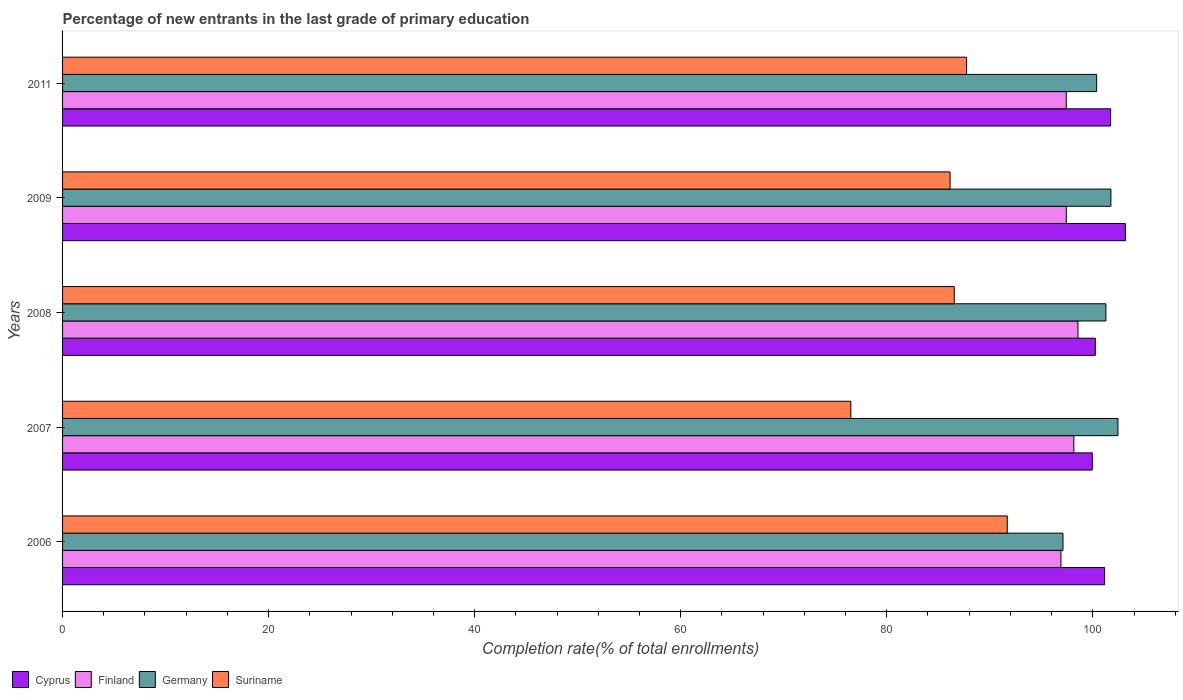How many different coloured bars are there?
Make the answer very short. 4. How many bars are there on the 3rd tick from the top?
Your answer should be very brief. 4. In how many cases, is the number of bars for a given year not equal to the number of legend labels?
Your answer should be very brief. 0. What is the percentage of new entrants in Finland in 2009?
Offer a terse response. 97.43. Across all years, what is the maximum percentage of new entrants in Suriname?
Offer a terse response. 91.7. Across all years, what is the minimum percentage of new entrants in Cyprus?
Provide a short and direct response. 99.95. In which year was the percentage of new entrants in Germany maximum?
Keep it short and to the point. 2007. In which year was the percentage of new entrants in Finland minimum?
Your answer should be very brief. 2006. What is the total percentage of new entrants in Cyprus in the graph?
Your answer should be compact. 506.24. What is the difference between the percentage of new entrants in Suriname in 2006 and that in 2008?
Give a very brief answer. 5.15. What is the difference between the percentage of new entrants in Germany in 2009 and the percentage of new entrants in Finland in 2008?
Offer a very short reply. 3.2. What is the average percentage of new entrants in Suriname per year?
Your answer should be compact. 85.73. In the year 2008, what is the difference between the percentage of new entrants in Germany and percentage of new entrants in Finland?
Keep it short and to the point. 2.71. What is the ratio of the percentage of new entrants in Germany in 2008 to that in 2009?
Provide a succinct answer. 1. Is the percentage of new entrants in Cyprus in 2006 less than that in 2009?
Your answer should be very brief. Yes. Is the difference between the percentage of new entrants in Germany in 2006 and 2009 greater than the difference between the percentage of new entrants in Finland in 2006 and 2009?
Your answer should be very brief. No. What is the difference between the highest and the second highest percentage of new entrants in Finland?
Provide a short and direct response. 0.4. What is the difference between the highest and the lowest percentage of new entrants in Finland?
Ensure brevity in your answer.  1.65. What does the 1st bar from the top in 2007 represents?
Your response must be concise. Suriname. What does the 4th bar from the bottom in 2008 represents?
Ensure brevity in your answer.  Suriname. Is it the case that in every year, the sum of the percentage of new entrants in Germany and percentage of new entrants in Suriname is greater than the percentage of new entrants in Finland?
Give a very brief answer. Yes. Does the graph contain grids?
Ensure brevity in your answer.  No. How many legend labels are there?
Make the answer very short. 4. How are the legend labels stacked?
Ensure brevity in your answer.  Horizontal. What is the title of the graph?
Offer a very short reply. Percentage of new entrants in the last grade of primary education. What is the label or title of the X-axis?
Offer a very short reply. Completion rate(% of total enrollments). What is the label or title of the Y-axis?
Give a very brief answer. Years. What is the Completion rate(% of total enrollments) in Cyprus in 2006?
Make the answer very short. 101.15. What is the Completion rate(% of total enrollments) in Finland in 2006?
Your answer should be very brief. 96.91. What is the Completion rate(% of total enrollments) in Germany in 2006?
Ensure brevity in your answer.  97.11. What is the Completion rate(% of total enrollments) of Suriname in 2006?
Make the answer very short. 91.7. What is the Completion rate(% of total enrollments) of Cyprus in 2007?
Give a very brief answer. 99.95. What is the Completion rate(% of total enrollments) in Finland in 2007?
Provide a short and direct response. 98.16. What is the Completion rate(% of total enrollments) in Germany in 2007?
Make the answer very short. 102.44. What is the Completion rate(% of total enrollments) in Suriname in 2007?
Provide a short and direct response. 76.51. What is the Completion rate(% of total enrollments) in Cyprus in 2008?
Offer a very short reply. 100.25. What is the Completion rate(% of total enrollments) in Finland in 2008?
Your answer should be very brief. 98.56. What is the Completion rate(% of total enrollments) of Germany in 2008?
Offer a very short reply. 101.27. What is the Completion rate(% of total enrollments) of Suriname in 2008?
Give a very brief answer. 86.55. What is the Completion rate(% of total enrollments) of Cyprus in 2009?
Your answer should be very brief. 103.16. What is the Completion rate(% of total enrollments) of Finland in 2009?
Your answer should be compact. 97.43. What is the Completion rate(% of total enrollments) in Germany in 2009?
Provide a succinct answer. 101.76. What is the Completion rate(% of total enrollments) of Suriname in 2009?
Keep it short and to the point. 86.15. What is the Completion rate(% of total enrollments) of Cyprus in 2011?
Offer a very short reply. 101.73. What is the Completion rate(% of total enrollments) of Finland in 2011?
Keep it short and to the point. 97.42. What is the Completion rate(% of total enrollments) in Germany in 2011?
Your response must be concise. 100.37. What is the Completion rate(% of total enrollments) in Suriname in 2011?
Provide a short and direct response. 87.75. Across all years, what is the maximum Completion rate(% of total enrollments) in Cyprus?
Your response must be concise. 103.16. Across all years, what is the maximum Completion rate(% of total enrollments) in Finland?
Provide a succinct answer. 98.56. Across all years, what is the maximum Completion rate(% of total enrollments) in Germany?
Provide a short and direct response. 102.44. Across all years, what is the maximum Completion rate(% of total enrollments) in Suriname?
Offer a terse response. 91.7. Across all years, what is the minimum Completion rate(% of total enrollments) in Cyprus?
Your answer should be very brief. 99.95. Across all years, what is the minimum Completion rate(% of total enrollments) of Finland?
Provide a succinct answer. 96.91. Across all years, what is the minimum Completion rate(% of total enrollments) in Germany?
Your response must be concise. 97.11. Across all years, what is the minimum Completion rate(% of total enrollments) in Suriname?
Ensure brevity in your answer.  76.51. What is the total Completion rate(% of total enrollments) in Cyprus in the graph?
Offer a very short reply. 506.24. What is the total Completion rate(% of total enrollments) in Finland in the graph?
Give a very brief answer. 488.48. What is the total Completion rate(% of total enrollments) in Germany in the graph?
Ensure brevity in your answer.  502.96. What is the total Completion rate(% of total enrollments) of Suriname in the graph?
Offer a terse response. 428.65. What is the difference between the Completion rate(% of total enrollments) of Cyprus in 2006 and that in 2007?
Your answer should be compact. 1.19. What is the difference between the Completion rate(% of total enrollments) in Finland in 2006 and that in 2007?
Provide a short and direct response. -1.25. What is the difference between the Completion rate(% of total enrollments) of Germany in 2006 and that in 2007?
Your response must be concise. -5.34. What is the difference between the Completion rate(% of total enrollments) in Suriname in 2006 and that in 2007?
Provide a succinct answer. 15.19. What is the difference between the Completion rate(% of total enrollments) in Finland in 2006 and that in 2008?
Provide a succinct answer. -1.65. What is the difference between the Completion rate(% of total enrollments) of Germany in 2006 and that in 2008?
Provide a succinct answer. -4.17. What is the difference between the Completion rate(% of total enrollments) of Suriname in 2006 and that in 2008?
Provide a short and direct response. 5.15. What is the difference between the Completion rate(% of total enrollments) in Cyprus in 2006 and that in 2009?
Keep it short and to the point. -2.01. What is the difference between the Completion rate(% of total enrollments) in Finland in 2006 and that in 2009?
Your response must be concise. -0.52. What is the difference between the Completion rate(% of total enrollments) of Germany in 2006 and that in 2009?
Offer a terse response. -4.65. What is the difference between the Completion rate(% of total enrollments) of Suriname in 2006 and that in 2009?
Offer a terse response. 5.55. What is the difference between the Completion rate(% of total enrollments) of Cyprus in 2006 and that in 2011?
Ensure brevity in your answer.  -0.59. What is the difference between the Completion rate(% of total enrollments) of Finland in 2006 and that in 2011?
Give a very brief answer. -0.52. What is the difference between the Completion rate(% of total enrollments) of Germany in 2006 and that in 2011?
Offer a very short reply. -3.27. What is the difference between the Completion rate(% of total enrollments) in Suriname in 2006 and that in 2011?
Your answer should be very brief. 3.95. What is the difference between the Completion rate(% of total enrollments) of Cyprus in 2007 and that in 2008?
Your answer should be very brief. -0.29. What is the difference between the Completion rate(% of total enrollments) of Finland in 2007 and that in 2008?
Provide a short and direct response. -0.4. What is the difference between the Completion rate(% of total enrollments) of Germany in 2007 and that in 2008?
Keep it short and to the point. 1.17. What is the difference between the Completion rate(% of total enrollments) in Suriname in 2007 and that in 2008?
Offer a terse response. -10.04. What is the difference between the Completion rate(% of total enrollments) in Cyprus in 2007 and that in 2009?
Your answer should be compact. -3.21. What is the difference between the Completion rate(% of total enrollments) of Finland in 2007 and that in 2009?
Your response must be concise. 0.73. What is the difference between the Completion rate(% of total enrollments) of Germany in 2007 and that in 2009?
Provide a succinct answer. 0.69. What is the difference between the Completion rate(% of total enrollments) in Suriname in 2007 and that in 2009?
Provide a short and direct response. -9.64. What is the difference between the Completion rate(% of total enrollments) in Cyprus in 2007 and that in 2011?
Make the answer very short. -1.78. What is the difference between the Completion rate(% of total enrollments) of Finland in 2007 and that in 2011?
Keep it short and to the point. 0.74. What is the difference between the Completion rate(% of total enrollments) in Germany in 2007 and that in 2011?
Make the answer very short. 2.07. What is the difference between the Completion rate(% of total enrollments) in Suriname in 2007 and that in 2011?
Provide a short and direct response. -11.23. What is the difference between the Completion rate(% of total enrollments) in Cyprus in 2008 and that in 2009?
Provide a short and direct response. -2.91. What is the difference between the Completion rate(% of total enrollments) in Finland in 2008 and that in 2009?
Your response must be concise. 1.13. What is the difference between the Completion rate(% of total enrollments) in Germany in 2008 and that in 2009?
Keep it short and to the point. -0.49. What is the difference between the Completion rate(% of total enrollments) of Suriname in 2008 and that in 2009?
Your answer should be compact. 0.41. What is the difference between the Completion rate(% of total enrollments) of Cyprus in 2008 and that in 2011?
Give a very brief answer. -1.49. What is the difference between the Completion rate(% of total enrollments) in Finland in 2008 and that in 2011?
Your response must be concise. 1.14. What is the difference between the Completion rate(% of total enrollments) of Germany in 2008 and that in 2011?
Provide a succinct answer. 0.9. What is the difference between the Completion rate(% of total enrollments) of Suriname in 2008 and that in 2011?
Your answer should be compact. -1.19. What is the difference between the Completion rate(% of total enrollments) in Cyprus in 2009 and that in 2011?
Ensure brevity in your answer.  1.43. What is the difference between the Completion rate(% of total enrollments) of Finland in 2009 and that in 2011?
Your answer should be compact. 0. What is the difference between the Completion rate(% of total enrollments) in Germany in 2009 and that in 2011?
Keep it short and to the point. 1.38. What is the difference between the Completion rate(% of total enrollments) in Suriname in 2009 and that in 2011?
Offer a terse response. -1.6. What is the difference between the Completion rate(% of total enrollments) of Cyprus in 2006 and the Completion rate(% of total enrollments) of Finland in 2007?
Provide a short and direct response. 2.99. What is the difference between the Completion rate(% of total enrollments) of Cyprus in 2006 and the Completion rate(% of total enrollments) of Germany in 2007?
Provide a succinct answer. -1.3. What is the difference between the Completion rate(% of total enrollments) in Cyprus in 2006 and the Completion rate(% of total enrollments) in Suriname in 2007?
Your response must be concise. 24.63. What is the difference between the Completion rate(% of total enrollments) in Finland in 2006 and the Completion rate(% of total enrollments) in Germany in 2007?
Ensure brevity in your answer.  -5.54. What is the difference between the Completion rate(% of total enrollments) in Finland in 2006 and the Completion rate(% of total enrollments) in Suriname in 2007?
Your answer should be compact. 20.4. What is the difference between the Completion rate(% of total enrollments) of Germany in 2006 and the Completion rate(% of total enrollments) of Suriname in 2007?
Keep it short and to the point. 20.6. What is the difference between the Completion rate(% of total enrollments) in Cyprus in 2006 and the Completion rate(% of total enrollments) in Finland in 2008?
Your answer should be very brief. 2.58. What is the difference between the Completion rate(% of total enrollments) of Cyprus in 2006 and the Completion rate(% of total enrollments) of Germany in 2008?
Your response must be concise. -0.13. What is the difference between the Completion rate(% of total enrollments) in Cyprus in 2006 and the Completion rate(% of total enrollments) in Suriname in 2008?
Give a very brief answer. 14.59. What is the difference between the Completion rate(% of total enrollments) in Finland in 2006 and the Completion rate(% of total enrollments) in Germany in 2008?
Your response must be concise. -4.36. What is the difference between the Completion rate(% of total enrollments) of Finland in 2006 and the Completion rate(% of total enrollments) of Suriname in 2008?
Offer a terse response. 10.36. What is the difference between the Completion rate(% of total enrollments) of Germany in 2006 and the Completion rate(% of total enrollments) of Suriname in 2008?
Your answer should be very brief. 10.55. What is the difference between the Completion rate(% of total enrollments) of Cyprus in 2006 and the Completion rate(% of total enrollments) of Finland in 2009?
Make the answer very short. 3.72. What is the difference between the Completion rate(% of total enrollments) of Cyprus in 2006 and the Completion rate(% of total enrollments) of Germany in 2009?
Provide a succinct answer. -0.61. What is the difference between the Completion rate(% of total enrollments) in Cyprus in 2006 and the Completion rate(% of total enrollments) in Suriname in 2009?
Provide a short and direct response. 15. What is the difference between the Completion rate(% of total enrollments) of Finland in 2006 and the Completion rate(% of total enrollments) of Germany in 2009?
Offer a very short reply. -4.85. What is the difference between the Completion rate(% of total enrollments) in Finland in 2006 and the Completion rate(% of total enrollments) in Suriname in 2009?
Offer a terse response. 10.76. What is the difference between the Completion rate(% of total enrollments) of Germany in 2006 and the Completion rate(% of total enrollments) of Suriname in 2009?
Your answer should be very brief. 10.96. What is the difference between the Completion rate(% of total enrollments) in Cyprus in 2006 and the Completion rate(% of total enrollments) in Finland in 2011?
Provide a succinct answer. 3.72. What is the difference between the Completion rate(% of total enrollments) in Cyprus in 2006 and the Completion rate(% of total enrollments) in Germany in 2011?
Your answer should be compact. 0.77. What is the difference between the Completion rate(% of total enrollments) of Cyprus in 2006 and the Completion rate(% of total enrollments) of Suriname in 2011?
Make the answer very short. 13.4. What is the difference between the Completion rate(% of total enrollments) of Finland in 2006 and the Completion rate(% of total enrollments) of Germany in 2011?
Your response must be concise. -3.47. What is the difference between the Completion rate(% of total enrollments) in Finland in 2006 and the Completion rate(% of total enrollments) in Suriname in 2011?
Keep it short and to the point. 9.16. What is the difference between the Completion rate(% of total enrollments) in Germany in 2006 and the Completion rate(% of total enrollments) in Suriname in 2011?
Give a very brief answer. 9.36. What is the difference between the Completion rate(% of total enrollments) in Cyprus in 2007 and the Completion rate(% of total enrollments) in Finland in 2008?
Your answer should be compact. 1.39. What is the difference between the Completion rate(% of total enrollments) in Cyprus in 2007 and the Completion rate(% of total enrollments) in Germany in 2008?
Ensure brevity in your answer.  -1.32. What is the difference between the Completion rate(% of total enrollments) in Cyprus in 2007 and the Completion rate(% of total enrollments) in Suriname in 2008?
Make the answer very short. 13.4. What is the difference between the Completion rate(% of total enrollments) of Finland in 2007 and the Completion rate(% of total enrollments) of Germany in 2008?
Make the answer very short. -3.11. What is the difference between the Completion rate(% of total enrollments) in Finland in 2007 and the Completion rate(% of total enrollments) in Suriname in 2008?
Give a very brief answer. 11.61. What is the difference between the Completion rate(% of total enrollments) of Germany in 2007 and the Completion rate(% of total enrollments) of Suriname in 2008?
Your response must be concise. 15.89. What is the difference between the Completion rate(% of total enrollments) of Cyprus in 2007 and the Completion rate(% of total enrollments) of Finland in 2009?
Your response must be concise. 2.52. What is the difference between the Completion rate(% of total enrollments) in Cyprus in 2007 and the Completion rate(% of total enrollments) in Germany in 2009?
Your answer should be very brief. -1.81. What is the difference between the Completion rate(% of total enrollments) of Cyprus in 2007 and the Completion rate(% of total enrollments) of Suriname in 2009?
Your answer should be very brief. 13.8. What is the difference between the Completion rate(% of total enrollments) in Finland in 2007 and the Completion rate(% of total enrollments) in Germany in 2009?
Provide a short and direct response. -3.6. What is the difference between the Completion rate(% of total enrollments) of Finland in 2007 and the Completion rate(% of total enrollments) of Suriname in 2009?
Your response must be concise. 12.01. What is the difference between the Completion rate(% of total enrollments) of Germany in 2007 and the Completion rate(% of total enrollments) of Suriname in 2009?
Provide a short and direct response. 16.3. What is the difference between the Completion rate(% of total enrollments) in Cyprus in 2007 and the Completion rate(% of total enrollments) in Finland in 2011?
Make the answer very short. 2.53. What is the difference between the Completion rate(% of total enrollments) of Cyprus in 2007 and the Completion rate(% of total enrollments) of Germany in 2011?
Offer a terse response. -0.42. What is the difference between the Completion rate(% of total enrollments) of Cyprus in 2007 and the Completion rate(% of total enrollments) of Suriname in 2011?
Your answer should be very brief. 12.21. What is the difference between the Completion rate(% of total enrollments) in Finland in 2007 and the Completion rate(% of total enrollments) in Germany in 2011?
Give a very brief answer. -2.21. What is the difference between the Completion rate(% of total enrollments) of Finland in 2007 and the Completion rate(% of total enrollments) of Suriname in 2011?
Provide a short and direct response. 10.42. What is the difference between the Completion rate(% of total enrollments) in Germany in 2007 and the Completion rate(% of total enrollments) in Suriname in 2011?
Give a very brief answer. 14.7. What is the difference between the Completion rate(% of total enrollments) of Cyprus in 2008 and the Completion rate(% of total enrollments) of Finland in 2009?
Your answer should be compact. 2.82. What is the difference between the Completion rate(% of total enrollments) in Cyprus in 2008 and the Completion rate(% of total enrollments) in Germany in 2009?
Provide a short and direct response. -1.51. What is the difference between the Completion rate(% of total enrollments) in Cyprus in 2008 and the Completion rate(% of total enrollments) in Suriname in 2009?
Ensure brevity in your answer.  14.1. What is the difference between the Completion rate(% of total enrollments) in Finland in 2008 and the Completion rate(% of total enrollments) in Germany in 2009?
Your answer should be compact. -3.2. What is the difference between the Completion rate(% of total enrollments) of Finland in 2008 and the Completion rate(% of total enrollments) of Suriname in 2009?
Provide a short and direct response. 12.42. What is the difference between the Completion rate(% of total enrollments) in Germany in 2008 and the Completion rate(% of total enrollments) in Suriname in 2009?
Your answer should be compact. 15.13. What is the difference between the Completion rate(% of total enrollments) of Cyprus in 2008 and the Completion rate(% of total enrollments) of Finland in 2011?
Provide a succinct answer. 2.82. What is the difference between the Completion rate(% of total enrollments) of Cyprus in 2008 and the Completion rate(% of total enrollments) of Germany in 2011?
Ensure brevity in your answer.  -0.13. What is the difference between the Completion rate(% of total enrollments) in Cyprus in 2008 and the Completion rate(% of total enrollments) in Suriname in 2011?
Provide a succinct answer. 12.5. What is the difference between the Completion rate(% of total enrollments) of Finland in 2008 and the Completion rate(% of total enrollments) of Germany in 2011?
Give a very brief answer. -1.81. What is the difference between the Completion rate(% of total enrollments) in Finland in 2008 and the Completion rate(% of total enrollments) in Suriname in 2011?
Provide a succinct answer. 10.82. What is the difference between the Completion rate(% of total enrollments) of Germany in 2008 and the Completion rate(% of total enrollments) of Suriname in 2011?
Your answer should be compact. 13.53. What is the difference between the Completion rate(% of total enrollments) in Cyprus in 2009 and the Completion rate(% of total enrollments) in Finland in 2011?
Ensure brevity in your answer.  5.74. What is the difference between the Completion rate(% of total enrollments) of Cyprus in 2009 and the Completion rate(% of total enrollments) of Germany in 2011?
Make the answer very short. 2.79. What is the difference between the Completion rate(% of total enrollments) in Cyprus in 2009 and the Completion rate(% of total enrollments) in Suriname in 2011?
Make the answer very short. 15.41. What is the difference between the Completion rate(% of total enrollments) in Finland in 2009 and the Completion rate(% of total enrollments) in Germany in 2011?
Your answer should be compact. -2.95. What is the difference between the Completion rate(% of total enrollments) in Finland in 2009 and the Completion rate(% of total enrollments) in Suriname in 2011?
Give a very brief answer. 9.68. What is the difference between the Completion rate(% of total enrollments) of Germany in 2009 and the Completion rate(% of total enrollments) of Suriname in 2011?
Your response must be concise. 14.01. What is the average Completion rate(% of total enrollments) in Cyprus per year?
Make the answer very short. 101.25. What is the average Completion rate(% of total enrollments) in Finland per year?
Provide a succinct answer. 97.7. What is the average Completion rate(% of total enrollments) in Germany per year?
Your answer should be compact. 100.59. What is the average Completion rate(% of total enrollments) in Suriname per year?
Provide a short and direct response. 85.73. In the year 2006, what is the difference between the Completion rate(% of total enrollments) in Cyprus and Completion rate(% of total enrollments) in Finland?
Make the answer very short. 4.24. In the year 2006, what is the difference between the Completion rate(% of total enrollments) in Cyprus and Completion rate(% of total enrollments) in Germany?
Keep it short and to the point. 4.04. In the year 2006, what is the difference between the Completion rate(% of total enrollments) of Cyprus and Completion rate(% of total enrollments) of Suriname?
Provide a short and direct response. 9.45. In the year 2006, what is the difference between the Completion rate(% of total enrollments) in Finland and Completion rate(% of total enrollments) in Germany?
Ensure brevity in your answer.  -0.2. In the year 2006, what is the difference between the Completion rate(% of total enrollments) in Finland and Completion rate(% of total enrollments) in Suriname?
Ensure brevity in your answer.  5.21. In the year 2006, what is the difference between the Completion rate(% of total enrollments) of Germany and Completion rate(% of total enrollments) of Suriname?
Ensure brevity in your answer.  5.41. In the year 2007, what is the difference between the Completion rate(% of total enrollments) of Cyprus and Completion rate(% of total enrollments) of Finland?
Offer a terse response. 1.79. In the year 2007, what is the difference between the Completion rate(% of total enrollments) of Cyprus and Completion rate(% of total enrollments) of Germany?
Ensure brevity in your answer.  -2.49. In the year 2007, what is the difference between the Completion rate(% of total enrollments) in Cyprus and Completion rate(% of total enrollments) in Suriname?
Your answer should be very brief. 23.44. In the year 2007, what is the difference between the Completion rate(% of total enrollments) in Finland and Completion rate(% of total enrollments) in Germany?
Provide a short and direct response. -4.28. In the year 2007, what is the difference between the Completion rate(% of total enrollments) in Finland and Completion rate(% of total enrollments) in Suriname?
Offer a terse response. 21.65. In the year 2007, what is the difference between the Completion rate(% of total enrollments) of Germany and Completion rate(% of total enrollments) of Suriname?
Offer a very short reply. 25.93. In the year 2008, what is the difference between the Completion rate(% of total enrollments) in Cyprus and Completion rate(% of total enrollments) in Finland?
Your answer should be compact. 1.68. In the year 2008, what is the difference between the Completion rate(% of total enrollments) of Cyprus and Completion rate(% of total enrollments) of Germany?
Offer a very short reply. -1.03. In the year 2008, what is the difference between the Completion rate(% of total enrollments) in Cyprus and Completion rate(% of total enrollments) in Suriname?
Make the answer very short. 13.69. In the year 2008, what is the difference between the Completion rate(% of total enrollments) of Finland and Completion rate(% of total enrollments) of Germany?
Your answer should be very brief. -2.71. In the year 2008, what is the difference between the Completion rate(% of total enrollments) in Finland and Completion rate(% of total enrollments) in Suriname?
Ensure brevity in your answer.  12.01. In the year 2008, what is the difference between the Completion rate(% of total enrollments) of Germany and Completion rate(% of total enrollments) of Suriname?
Keep it short and to the point. 14.72. In the year 2009, what is the difference between the Completion rate(% of total enrollments) in Cyprus and Completion rate(% of total enrollments) in Finland?
Your response must be concise. 5.73. In the year 2009, what is the difference between the Completion rate(% of total enrollments) of Cyprus and Completion rate(% of total enrollments) of Germany?
Offer a terse response. 1.4. In the year 2009, what is the difference between the Completion rate(% of total enrollments) in Cyprus and Completion rate(% of total enrollments) in Suriname?
Your response must be concise. 17.01. In the year 2009, what is the difference between the Completion rate(% of total enrollments) of Finland and Completion rate(% of total enrollments) of Germany?
Provide a short and direct response. -4.33. In the year 2009, what is the difference between the Completion rate(% of total enrollments) of Finland and Completion rate(% of total enrollments) of Suriname?
Make the answer very short. 11.28. In the year 2009, what is the difference between the Completion rate(% of total enrollments) of Germany and Completion rate(% of total enrollments) of Suriname?
Give a very brief answer. 15.61. In the year 2011, what is the difference between the Completion rate(% of total enrollments) in Cyprus and Completion rate(% of total enrollments) in Finland?
Your answer should be compact. 4.31. In the year 2011, what is the difference between the Completion rate(% of total enrollments) in Cyprus and Completion rate(% of total enrollments) in Germany?
Provide a succinct answer. 1.36. In the year 2011, what is the difference between the Completion rate(% of total enrollments) of Cyprus and Completion rate(% of total enrollments) of Suriname?
Your answer should be compact. 13.99. In the year 2011, what is the difference between the Completion rate(% of total enrollments) in Finland and Completion rate(% of total enrollments) in Germany?
Your answer should be compact. -2.95. In the year 2011, what is the difference between the Completion rate(% of total enrollments) of Finland and Completion rate(% of total enrollments) of Suriname?
Offer a very short reply. 9.68. In the year 2011, what is the difference between the Completion rate(% of total enrollments) in Germany and Completion rate(% of total enrollments) in Suriname?
Keep it short and to the point. 12.63. What is the ratio of the Completion rate(% of total enrollments) in Cyprus in 2006 to that in 2007?
Keep it short and to the point. 1.01. What is the ratio of the Completion rate(% of total enrollments) of Finland in 2006 to that in 2007?
Keep it short and to the point. 0.99. What is the ratio of the Completion rate(% of total enrollments) in Germany in 2006 to that in 2007?
Keep it short and to the point. 0.95. What is the ratio of the Completion rate(% of total enrollments) in Suriname in 2006 to that in 2007?
Provide a short and direct response. 1.2. What is the ratio of the Completion rate(% of total enrollments) of Finland in 2006 to that in 2008?
Offer a very short reply. 0.98. What is the ratio of the Completion rate(% of total enrollments) in Germany in 2006 to that in 2008?
Your answer should be compact. 0.96. What is the ratio of the Completion rate(% of total enrollments) in Suriname in 2006 to that in 2008?
Offer a terse response. 1.06. What is the ratio of the Completion rate(% of total enrollments) in Cyprus in 2006 to that in 2009?
Your answer should be compact. 0.98. What is the ratio of the Completion rate(% of total enrollments) in Finland in 2006 to that in 2009?
Keep it short and to the point. 0.99. What is the ratio of the Completion rate(% of total enrollments) in Germany in 2006 to that in 2009?
Offer a very short reply. 0.95. What is the ratio of the Completion rate(% of total enrollments) in Suriname in 2006 to that in 2009?
Make the answer very short. 1.06. What is the ratio of the Completion rate(% of total enrollments) of Cyprus in 2006 to that in 2011?
Make the answer very short. 0.99. What is the ratio of the Completion rate(% of total enrollments) of Germany in 2006 to that in 2011?
Offer a terse response. 0.97. What is the ratio of the Completion rate(% of total enrollments) in Suriname in 2006 to that in 2011?
Give a very brief answer. 1.04. What is the ratio of the Completion rate(% of total enrollments) in Germany in 2007 to that in 2008?
Your answer should be very brief. 1.01. What is the ratio of the Completion rate(% of total enrollments) in Suriname in 2007 to that in 2008?
Offer a terse response. 0.88. What is the ratio of the Completion rate(% of total enrollments) in Cyprus in 2007 to that in 2009?
Provide a succinct answer. 0.97. What is the ratio of the Completion rate(% of total enrollments) in Finland in 2007 to that in 2009?
Make the answer very short. 1.01. What is the ratio of the Completion rate(% of total enrollments) of Germany in 2007 to that in 2009?
Provide a succinct answer. 1.01. What is the ratio of the Completion rate(% of total enrollments) in Suriname in 2007 to that in 2009?
Offer a very short reply. 0.89. What is the ratio of the Completion rate(% of total enrollments) in Cyprus in 2007 to that in 2011?
Your answer should be compact. 0.98. What is the ratio of the Completion rate(% of total enrollments) of Finland in 2007 to that in 2011?
Offer a terse response. 1.01. What is the ratio of the Completion rate(% of total enrollments) in Germany in 2007 to that in 2011?
Offer a terse response. 1.02. What is the ratio of the Completion rate(% of total enrollments) in Suriname in 2007 to that in 2011?
Give a very brief answer. 0.87. What is the ratio of the Completion rate(% of total enrollments) in Cyprus in 2008 to that in 2009?
Keep it short and to the point. 0.97. What is the ratio of the Completion rate(% of total enrollments) of Finland in 2008 to that in 2009?
Offer a very short reply. 1.01. What is the ratio of the Completion rate(% of total enrollments) of Suriname in 2008 to that in 2009?
Your answer should be very brief. 1. What is the ratio of the Completion rate(% of total enrollments) of Cyprus in 2008 to that in 2011?
Your answer should be very brief. 0.99. What is the ratio of the Completion rate(% of total enrollments) in Finland in 2008 to that in 2011?
Provide a succinct answer. 1.01. What is the ratio of the Completion rate(% of total enrollments) in Germany in 2008 to that in 2011?
Make the answer very short. 1.01. What is the ratio of the Completion rate(% of total enrollments) of Suriname in 2008 to that in 2011?
Offer a terse response. 0.99. What is the ratio of the Completion rate(% of total enrollments) of Cyprus in 2009 to that in 2011?
Offer a very short reply. 1.01. What is the ratio of the Completion rate(% of total enrollments) of Finland in 2009 to that in 2011?
Provide a succinct answer. 1. What is the ratio of the Completion rate(% of total enrollments) in Germany in 2009 to that in 2011?
Ensure brevity in your answer.  1.01. What is the ratio of the Completion rate(% of total enrollments) in Suriname in 2009 to that in 2011?
Provide a succinct answer. 0.98. What is the difference between the highest and the second highest Completion rate(% of total enrollments) of Cyprus?
Your answer should be compact. 1.43. What is the difference between the highest and the second highest Completion rate(% of total enrollments) of Finland?
Ensure brevity in your answer.  0.4. What is the difference between the highest and the second highest Completion rate(% of total enrollments) of Germany?
Your answer should be compact. 0.69. What is the difference between the highest and the second highest Completion rate(% of total enrollments) in Suriname?
Keep it short and to the point. 3.95. What is the difference between the highest and the lowest Completion rate(% of total enrollments) of Cyprus?
Give a very brief answer. 3.21. What is the difference between the highest and the lowest Completion rate(% of total enrollments) in Finland?
Make the answer very short. 1.65. What is the difference between the highest and the lowest Completion rate(% of total enrollments) in Germany?
Your response must be concise. 5.34. What is the difference between the highest and the lowest Completion rate(% of total enrollments) in Suriname?
Give a very brief answer. 15.19. 